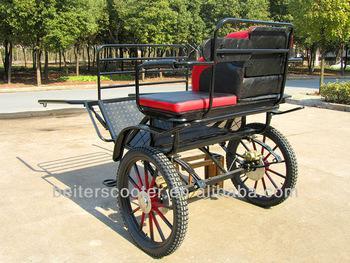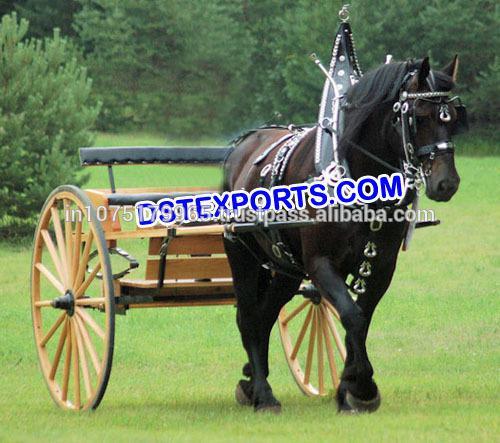The first image is the image on the left, the second image is the image on the right. Analyze the images presented: Is the assertion "At least one carriage is being pulled by a horse." valid? Answer yes or no. Yes. The first image is the image on the left, the second image is the image on the right. Analyze the images presented: Is the assertion "At least one buggy is attached to a horse." valid? Answer yes or no. Yes. 